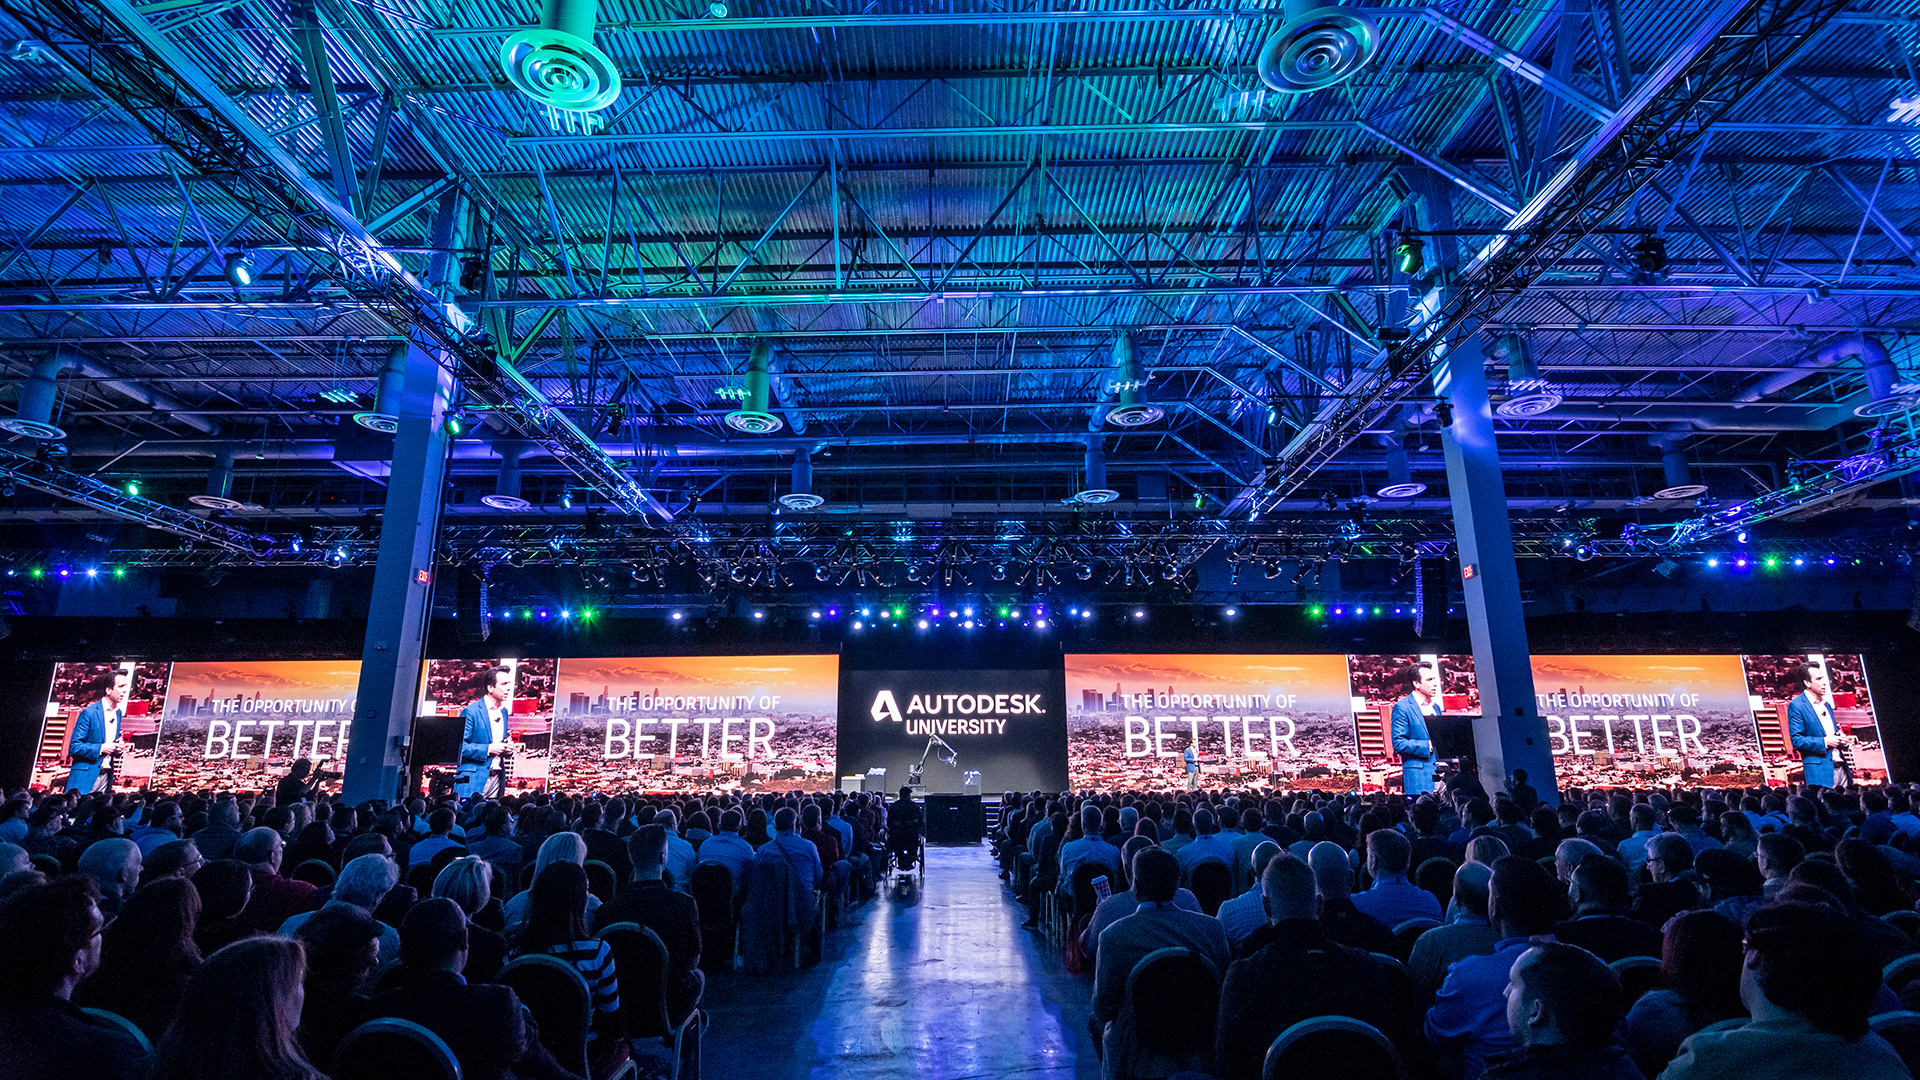Considering the branding visible on the backdrop, what kind of company or industry might be associated with this event? The branding on the backdrop, 'AUTODESK UNIVERSITY,' indicates that this event is associated with Autodesk, a prominent company known for developing comprehensive software solutions for various industries, including architecture, engineering, construction, manufacturing, media, and entertainment. Moreover, the word 'University' suggests that this is an educational or professional development event, likely a conference or seminar designed to educate and inform industry experts about the latest tools, technologies, and best practices pertinent to their work. 